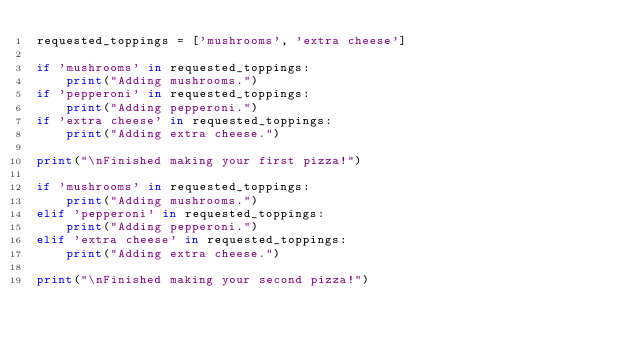Convert code to text. <code><loc_0><loc_0><loc_500><loc_500><_Python_>requested_toppings = ['mushrooms', 'extra cheese']

if 'mushrooms' in requested_toppings:
    print("Adding mushrooms.")
if 'pepperoni' in requested_toppings:
    print("Adding pepperoni.")
if 'extra cheese' in requested_toppings:
    print("Adding extra cheese.")

print("\nFinished making your first pizza!")

if 'mushrooms' in requested_toppings:
    print("Adding mushrooms.")
elif 'pepperoni' in requested_toppings:
    print("Adding pepperoni.")
elif 'extra cheese' in requested_toppings:
    print("Adding extra cheese.")

print("\nFinished making your second pizza!")</code> 